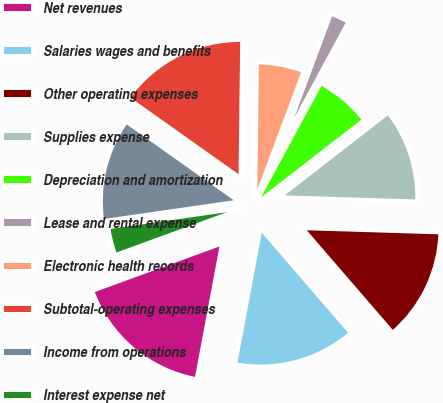<chart> <loc_0><loc_0><loc_500><loc_500><pie_chart><fcel>Net revenues<fcel>Salaries wages and benefits<fcel>Other operating expenses<fcel>Supplies expense<fcel>Depreciation and amortization<fcel>Lease and rental expense<fcel>Electronic health records<fcel>Subtotal-operating expenses<fcel>Income from operations<fcel>Interest expense net<nl><fcel>16.48%<fcel>14.28%<fcel>13.18%<fcel>10.99%<fcel>6.6%<fcel>2.21%<fcel>5.5%<fcel>15.38%<fcel>12.09%<fcel>3.3%<nl></chart> 